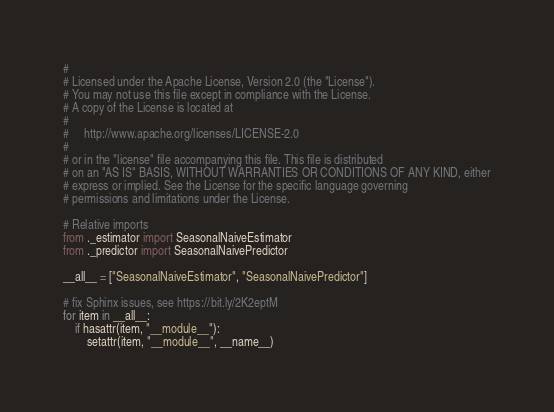Convert code to text. <code><loc_0><loc_0><loc_500><loc_500><_Python_>#
# Licensed under the Apache License, Version 2.0 (the "License").
# You may not use this file except in compliance with the License.
# A copy of the License is located at
#
#     http://www.apache.org/licenses/LICENSE-2.0
#
# or in the "license" file accompanying this file. This file is distributed
# on an "AS IS" BASIS, WITHOUT WARRANTIES OR CONDITIONS OF ANY KIND, either
# express or implied. See the License for the specific language governing
# permissions and limitations under the License.

# Relative imports
from ._estimator import SeasonalNaiveEstimator
from ._predictor import SeasonalNaivePredictor

__all__ = ["SeasonalNaiveEstimator", "SeasonalNaivePredictor"]

# fix Sphinx issues, see https://bit.ly/2K2eptM
for item in __all__:
    if hasattr(item, "__module__"):
        setattr(item, "__module__", __name__)
</code> 